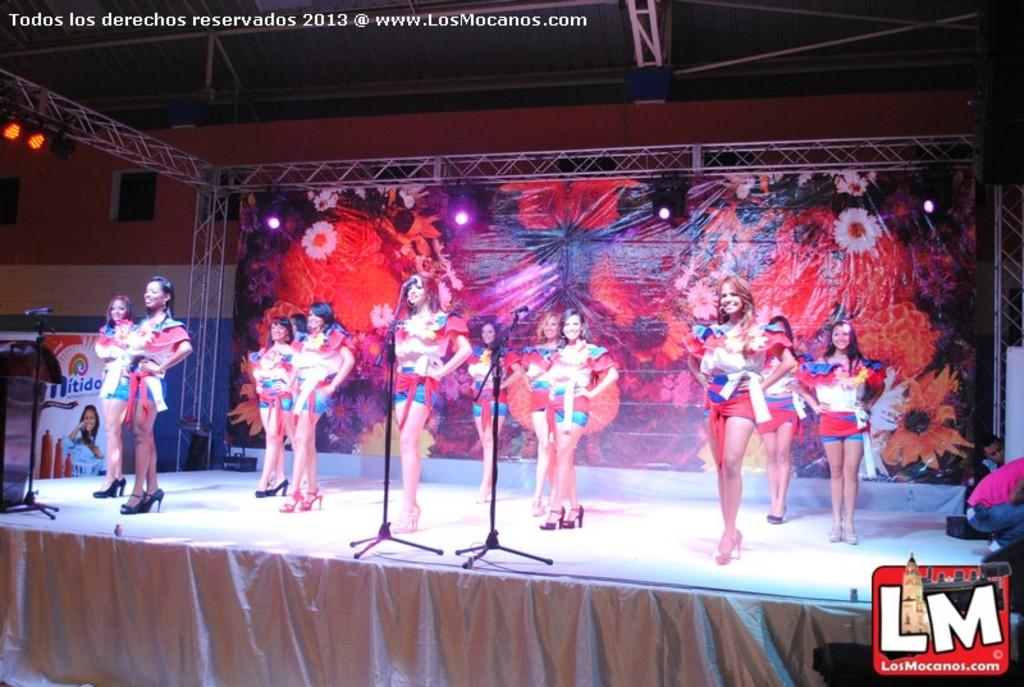What is happening on the stage in the image? There is a group of people standing on the stage. What object is present for the purpose of amplifying sound? There is a microphone in the image. What can be seen at the back of the stage? There is a banner at the back of the stage. What can be seen illuminating the stage? There are lights visible in the image. What type of sand can be seen on the stage in the image? There is no sand present on the stage in the image. What is the collective mindset of the people on the stage in the image? The image does not provide information about the mindset of the people on the stage. 